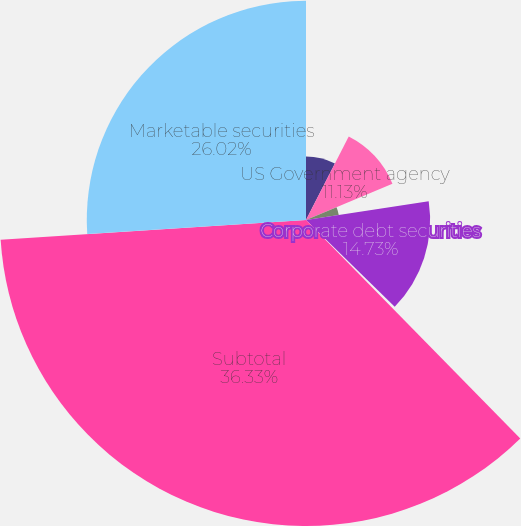<chart> <loc_0><loc_0><loc_500><loc_500><pie_chart><fcel>US Treasuries<fcel>US Government agency<fcel>Municipal bonds<fcel>Corporate debt securities<fcel>Sovereign/Multilateral<fcel>Subtotal<fcel>Marketable securities<nl><fcel>7.53%<fcel>11.13%<fcel>3.93%<fcel>14.73%<fcel>0.33%<fcel>36.32%<fcel>26.02%<nl></chart> 